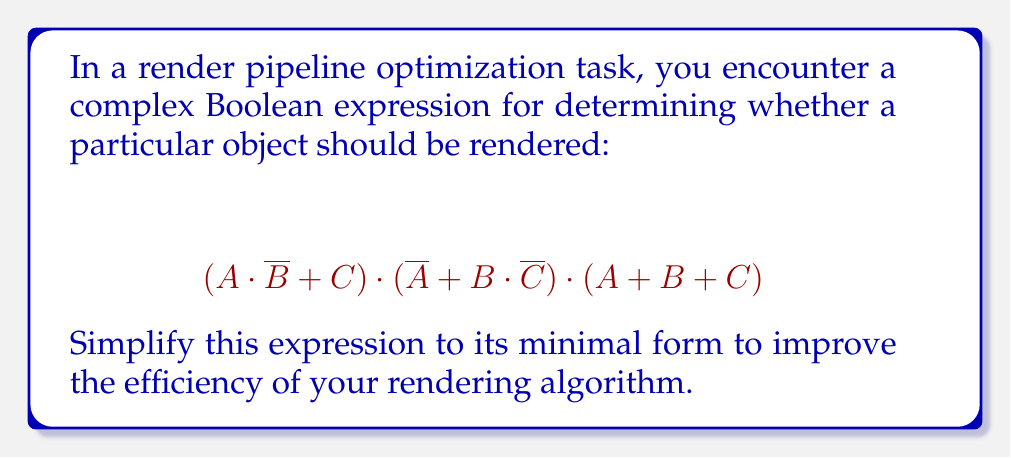Show me your answer to this math problem. Let's simplify this Boolean expression step-by-step:

1) First, let's apply the distributive law to expand the expression:
   $$(A \cdot \overline{B} + C) \cdot (\overline{A} + B \cdot \overline{C}) \cdot (A + B + C)$$
   $$= (A \cdot \overline{B} \cdot \overline{A} + A \cdot \overline{B} \cdot B \cdot \overline{C} + C \cdot \overline{A} + C \cdot B \cdot \overline{C}) \cdot (A + B + C)$$

2) Simplify using Boolean algebra laws:
   - $A \cdot \overline{A} = 0$
   - $\overline{B} \cdot B = 0$
   - $C \cdot \overline{C} = 0$
   
   This reduces our expression to:
   $$(0 + 0 + C \cdot \overline{A} + 0) \cdot (A + B + C)$$
   $$= (C \cdot \overline{A}) \cdot (A + B + C)$$

3) Distribute again:
   $$(C \cdot \overline{A} \cdot A) + (C \cdot \overline{A} \cdot B) + (C \cdot \overline{A} \cdot C)$$

4) Simplify:
   - $\overline{A} \cdot A = 0$
   - $C \cdot C = C$
   
   This gives us:
   $$0 + (C \cdot \overline{A} \cdot B) + (C \cdot \overline{A})$$

5) Factor out the common term:
   $$C \cdot \overline{A} \cdot (B + 1)$$

6) In Boolean algebra, $B + 1 = 1$ for any $B$, so our final simplified expression is:
   $$C \cdot \overline{A}$$
Answer: $C \cdot \overline{A}$ 